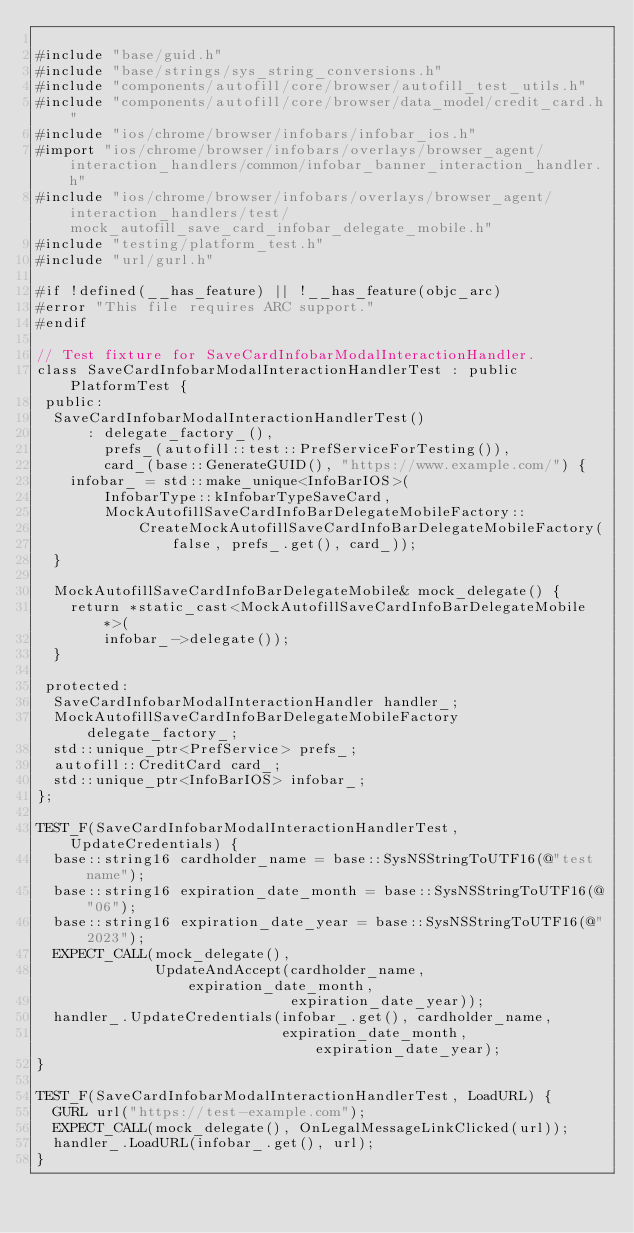Convert code to text. <code><loc_0><loc_0><loc_500><loc_500><_ObjectiveC_>
#include "base/guid.h"
#include "base/strings/sys_string_conversions.h"
#include "components/autofill/core/browser/autofill_test_utils.h"
#include "components/autofill/core/browser/data_model/credit_card.h"
#include "ios/chrome/browser/infobars/infobar_ios.h"
#import "ios/chrome/browser/infobars/overlays/browser_agent/interaction_handlers/common/infobar_banner_interaction_handler.h"
#include "ios/chrome/browser/infobars/overlays/browser_agent/interaction_handlers/test/mock_autofill_save_card_infobar_delegate_mobile.h"
#include "testing/platform_test.h"
#include "url/gurl.h"

#if !defined(__has_feature) || !__has_feature(objc_arc)
#error "This file requires ARC support."
#endif

// Test fixture for SaveCardInfobarModalInteractionHandler.
class SaveCardInfobarModalInteractionHandlerTest : public PlatformTest {
 public:
  SaveCardInfobarModalInteractionHandlerTest()
      : delegate_factory_(),
        prefs_(autofill::test::PrefServiceForTesting()),
        card_(base::GenerateGUID(), "https://www.example.com/") {
    infobar_ = std::make_unique<InfoBarIOS>(
        InfobarType::kInfobarTypeSaveCard,
        MockAutofillSaveCardInfoBarDelegateMobileFactory::
            CreateMockAutofillSaveCardInfoBarDelegateMobileFactory(
                false, prefs_.get(), card_));
  }

  MockAutofillSaveCardInfoBarDelegateMobile& mock_delegate() {
    return *static_cast<MockAutofillSaveCardInfoBarDelegateMobile*>(
        infobar_->delegate());
  }

 protected:
  SaveCardInfobarModalInteractionHandler handler_;
  MockAutofillSaveCardInfoBarDelegateMobileFactory delegate_factory_;
  std::unique_ptr<PrefService> prefs_;
  autofill::CreditCard card_;
  std::unique_ptr<InfoBarIOS> infobar_;
};

TEST_F(SaveCardInfobarModalInteractionHandlerTest, UpdateCredentials) {
  base::string16 cardholder_name = base::SysNSStringToUTF16(@"test name");
  base::string16 expiration_date_month = base::SysNSStringToUTF16(@"06");
  base::string16 expiration_date_year = base::SysNSStringToUTF16(@"2023");
  EXPECT_CALL(mock_delegate(),
              UpdateAndAccept(cardholder_name, expiration_date_month,
                              expiration_date_year));
  handler_.UpdateCredentials(infobar_.get(), cardholder_name,
                             expiration_date_month, expiration_date_year);
}

TEST_F(SaveCardInfobarModalInteractionHandlerTest, LoadURL) {
  GURL url("https://test-example.com");
  EXPECT_CALL(mock_delegate(), OnLegalMessageLinkClicked(url));
  handler_.LoadURL(infobar_.get(), url);
}
</code> 